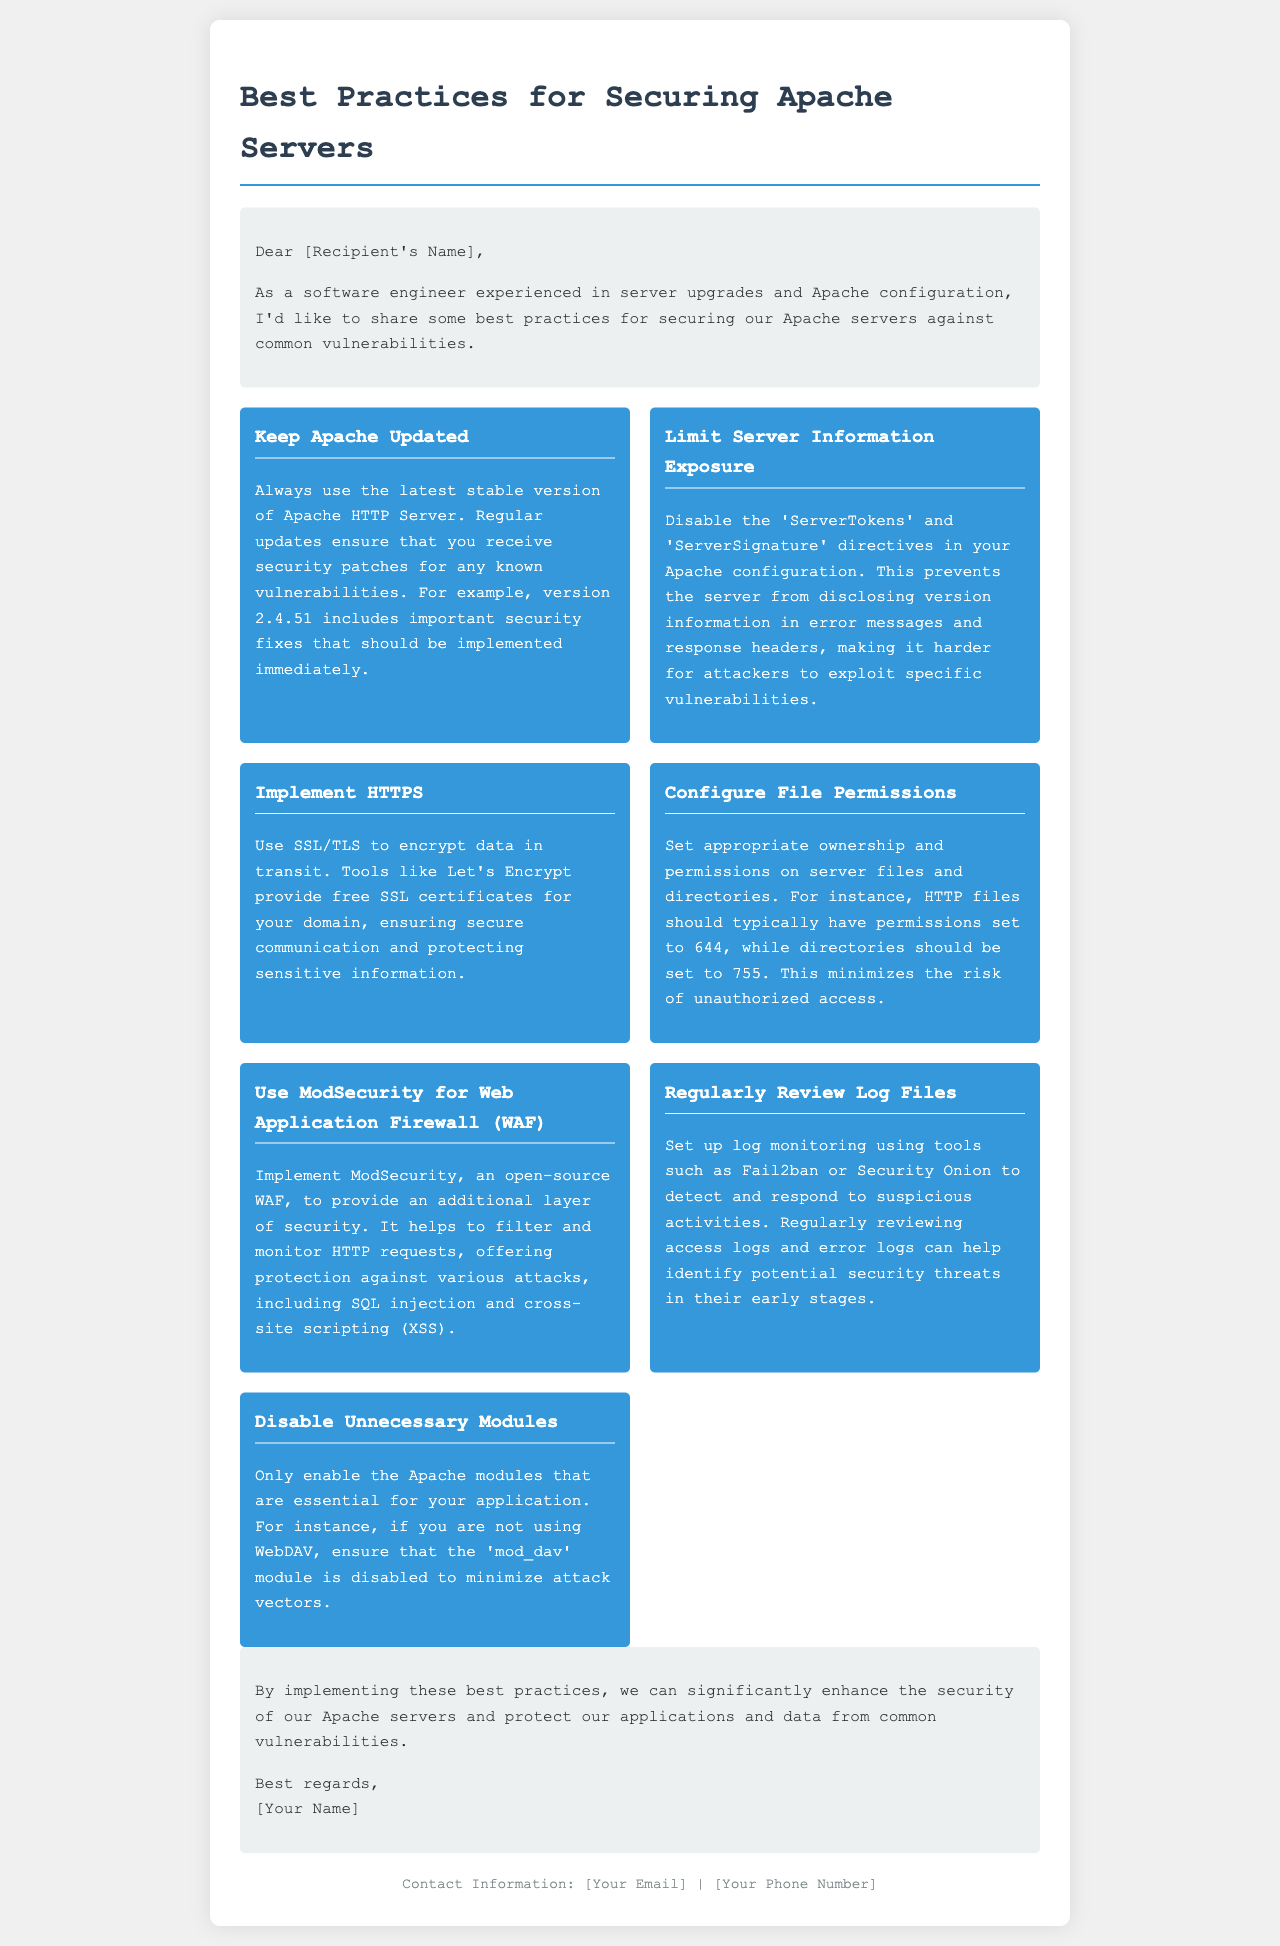What is the main topic of the letter? The main topic of the letter is the best practices for securing Apache servers.
Answer: Best Practices for Securing Apache Servers Who is the letter addressed to? The letter is addressed to a recipient who is not specified in the document.
Answer: [Recipient's Name] What version of Apache includes important security fixes? The document mentions a specific version of Apache that includes important security fixes.
Answer: 2.4.51 What should be set to minimize the risk of unauthorized access? The document suggests specific settings for server files and directories.
Answer: Ownership and permissions What tool is recommended for monitoring suspicious activities? The document provides a suggestion for a tool used to monitor logs for security threats.
Answer: Fail2ban How many best practices are listed in the letter? The document enumerates the specific practices included in the letter.
Answer: Seven What is the purpose of implementing ModSecurity? The document describes ModSecurity’s role in enhancing security on Apache servers.
Answer: Additional layer of security What is one of the first steps in securing an Apache server? The letter indicates a key action item necessary for server security at the start.
Answer: Keep Apache Updated 